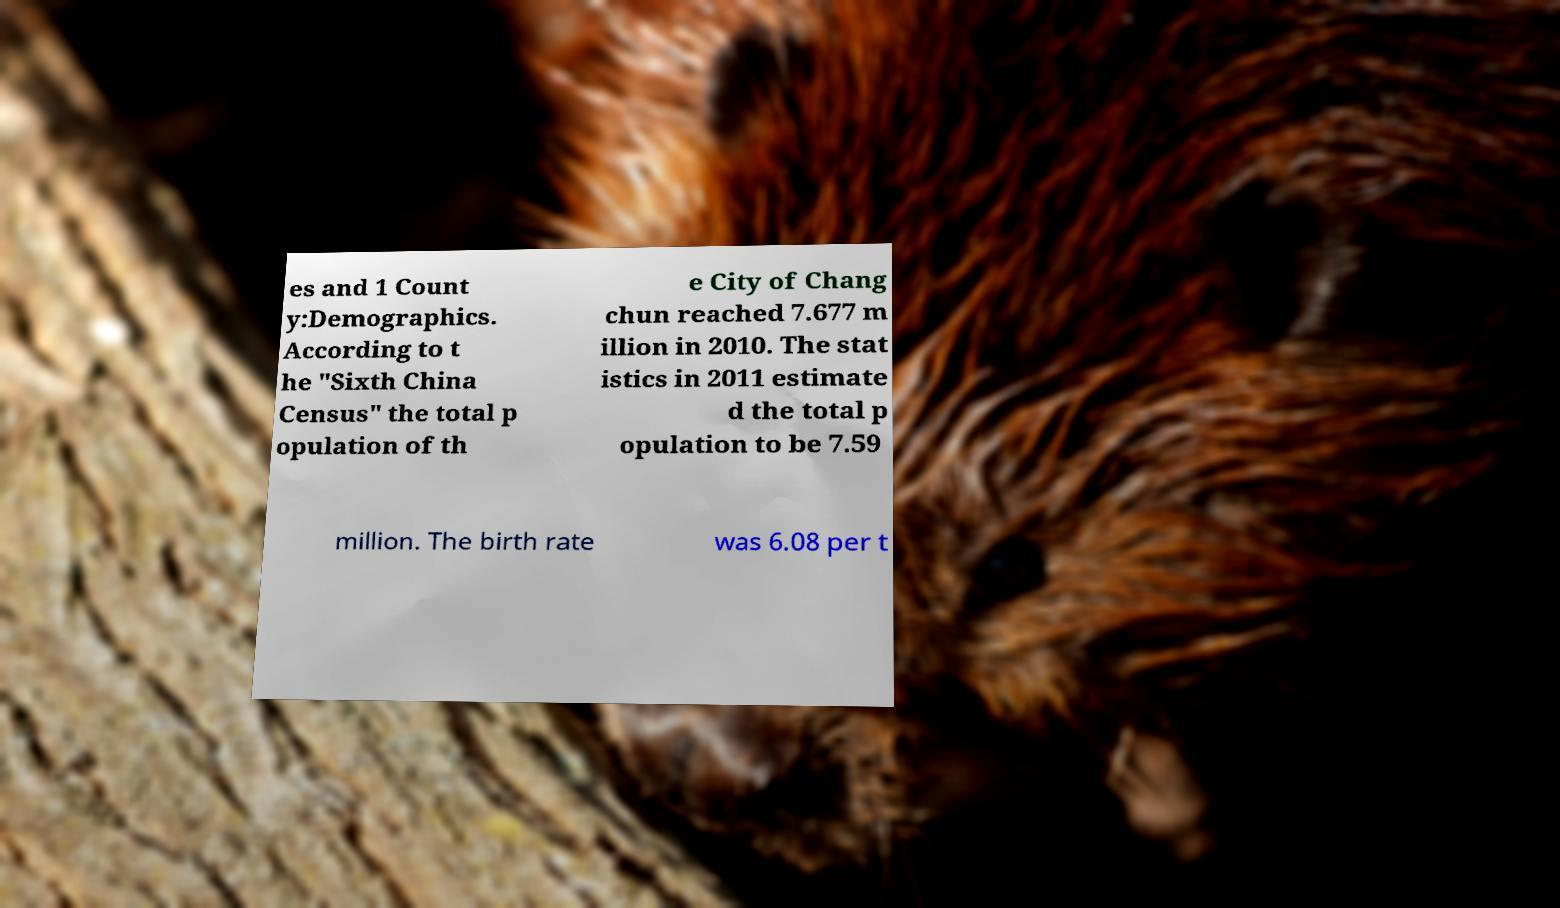There's text embedded in this image that I need extracted. Can you transcribe it verbatim? es and 1 Count y:Demographics. According to t he "Sixth China Census" the total p opulation of th e City of Chang chun reached 7.677 m illion in 2010. The stat istics in 2011 estimate d the total p opulation to be 7.59 million. The birth rate was 6.08 per t 